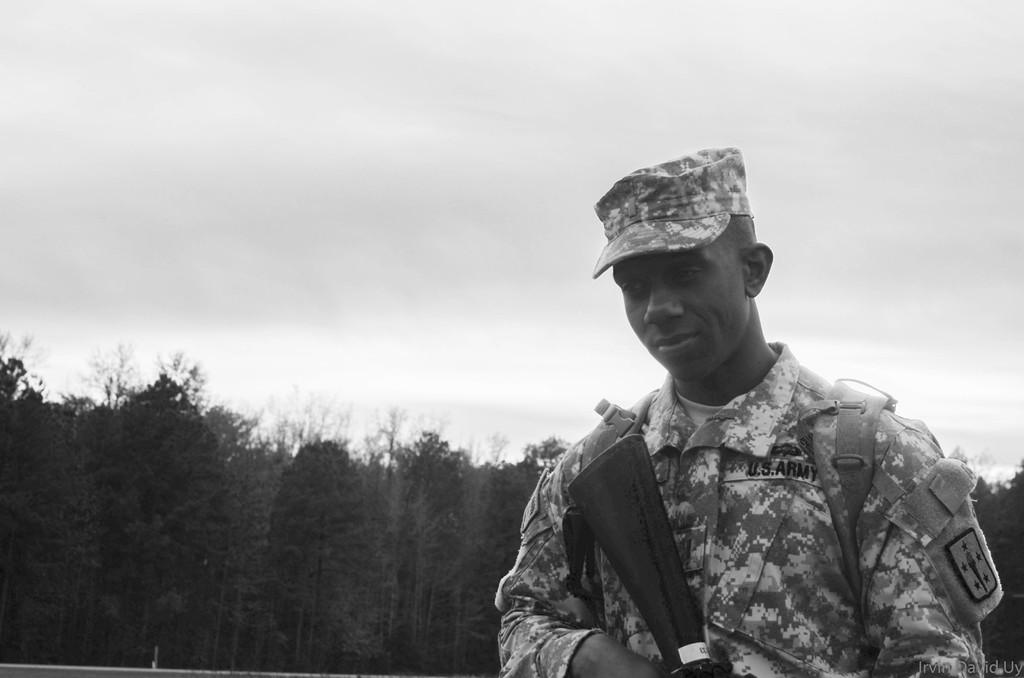What is the person on the right side of the image wearing? The person is wearing a uniform and a cap. What is the person holding in the image? The person is holding a gun. What can be seen in the background of the image? There are trees and the ground visible in the background. What is visible in the sky in the image? There are clouds in the sky. How many zebras can be seen grazing in the background of the image? There are no zebras present in the image; it features a person in a uniform holding a gun with trees and clouds in the background. What type of tree is the person leaning against in the image? There is no tree present in the image for the person to lean against. 